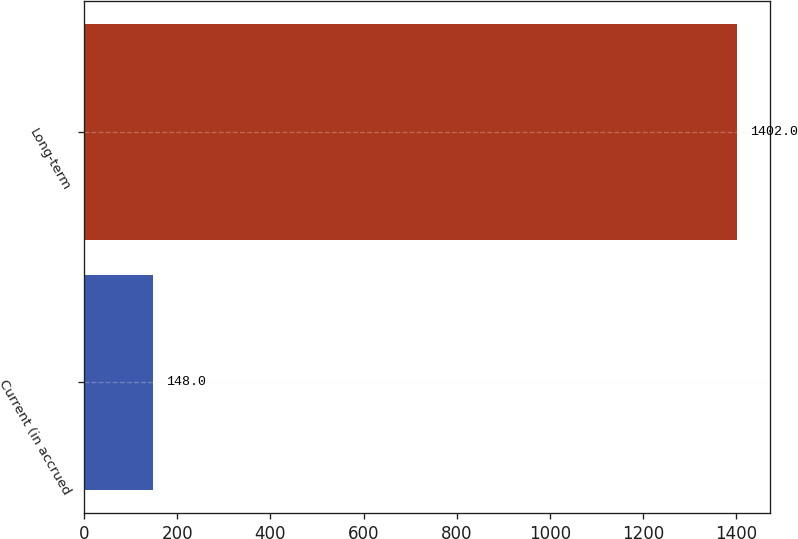<chart> <loc_0><loc_0><loc_500><loc_500><bar_chart><fcel>Current (in accrued<fcel>Long-term<nl><fcel>148<fcel>1402<nl></chart> 